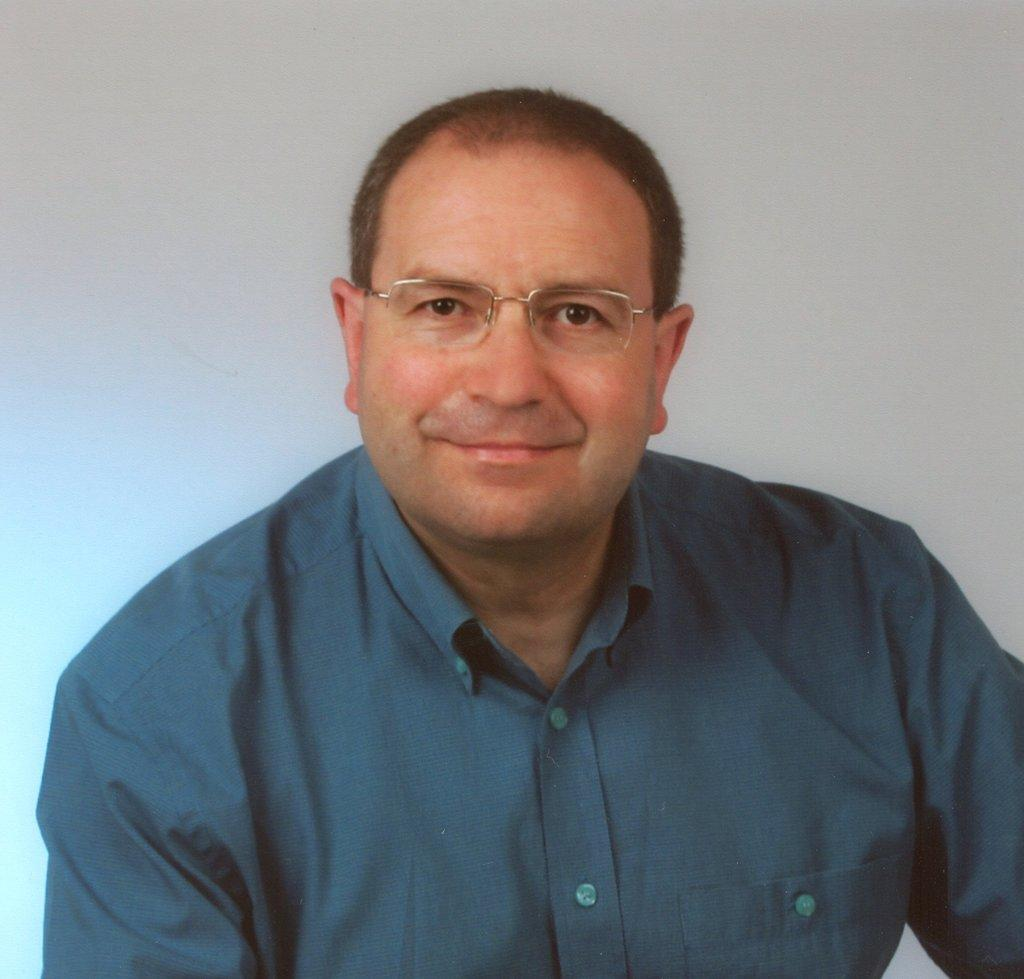Who is in the image? There is a person in the image. What is the person wearing? The person is wearing a blue shirt. What is the person's facial expression? The person is smiling. What can be seen in the background of the image? There is a white wall in the background of the image. How does the zephyr affect the person's hair in the image? There is no zephyr present in the image, so it cannot affect the person's hair. 